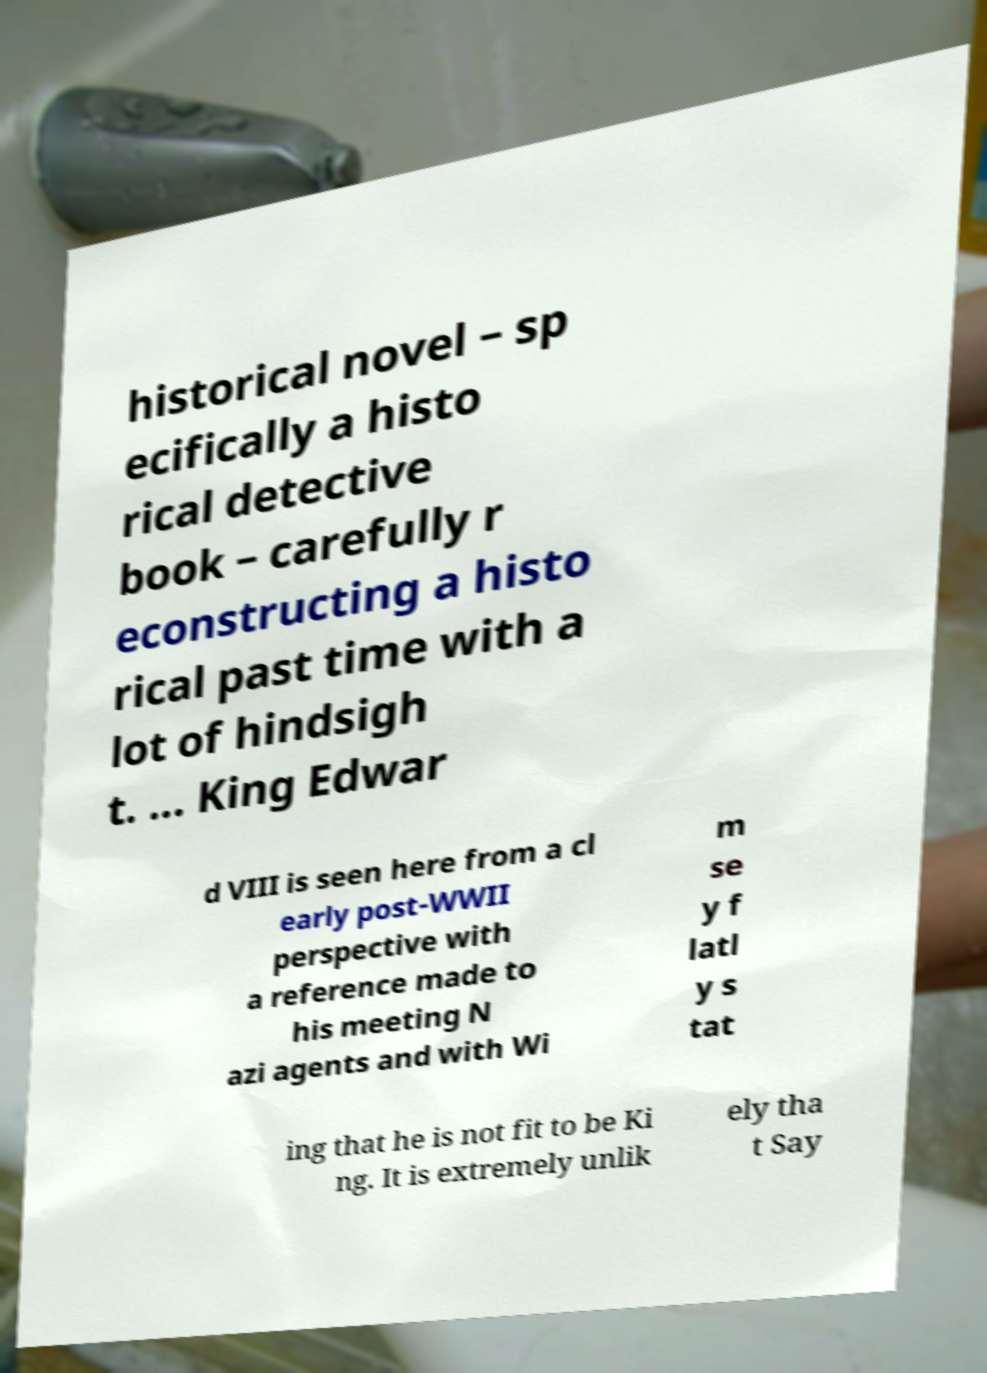Please read and relay the text visible in this image. What does it say? historical novel – sp ecifically a histo rical detective book – carefully r econstructing a histo rical past time with a lot of hindsigh t. ... King Edwar d VIII is seen here from a cl early post-WWII perspective with a reference made to his meeting N azi agents and with Wi m se y f latl y s tat ing that he is not fit to be Ki ng. It is extremely unlik ely tha t Say 